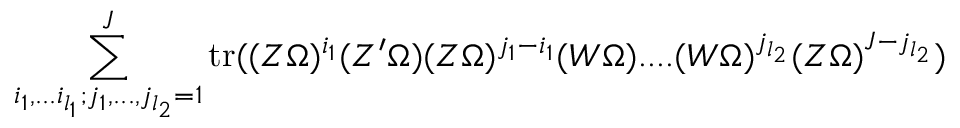Convert formula to latex. <formula><loc_0><loc_0><loc_500><loc_500>\sum _ { i _ { 1 } , \dots i _ { l _ { 1 } } ; j _ { 1 } , \dots , j _ { l _ { 2 } } = 1 } ^ { J } t r ( ( Z \Omega ) ^ { i _ { 1 } } ( Z ^ { \prime } \Omega ) ( Z \Omega ) ^ { j _ { 1 } - i _ { 1 } } ( W \Omega ) \cdots ( W \Omega ) ^ { j _ { l _ { 2 } } } ( Z \Omega ) ^ { J - j _ { l _ { 2 } } } )</formula> 